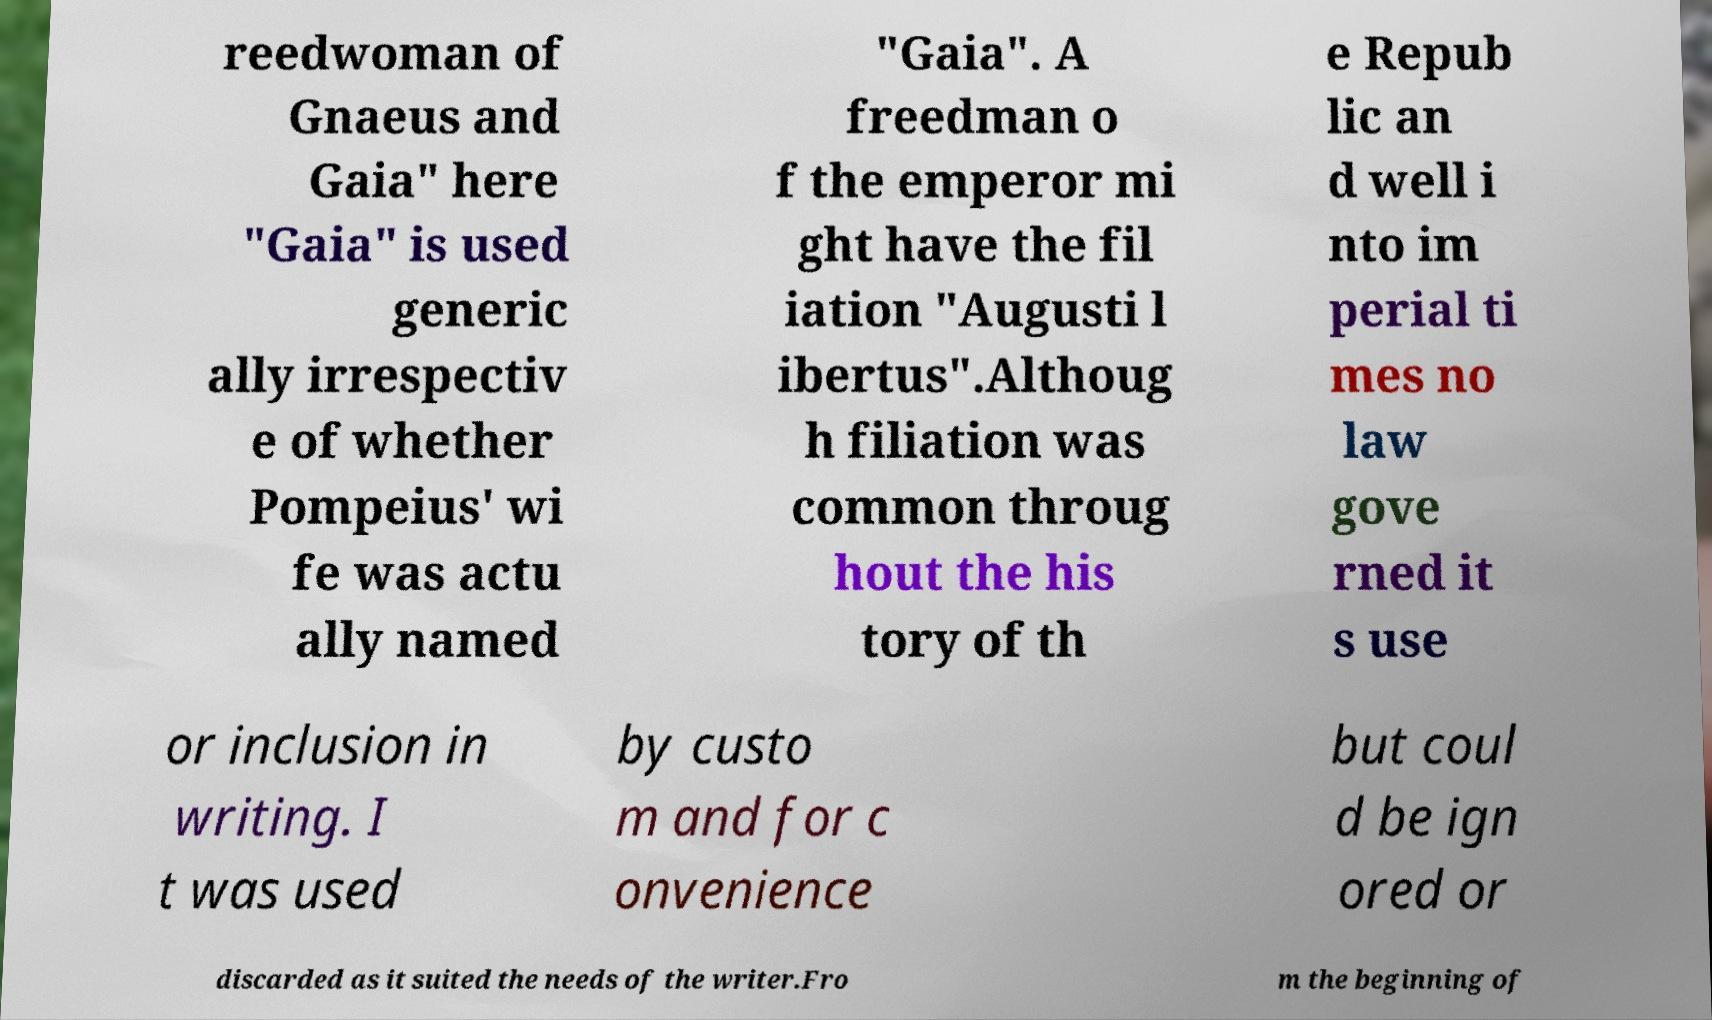Please identify and transcribe the text found in this image. reedwoman of Gnaeus and Gaia" here "Gaia" is used generic ally irrespectiv e of whether Pompeius' wi fe was actu ally named "Gaia". A freedman o f the emperor mi ght have the fil iation "Augusti l ibertus".Althoug h filiation was common throug hout the his tory of th e Repub lic an d well i nto im perial ti mes no law gove rned it s use or inclusion in writing. I t was used by custo m and for c onvenience but coul d be ign ored or discarded as it suited the needs of the writer.Fro m the beginning of 